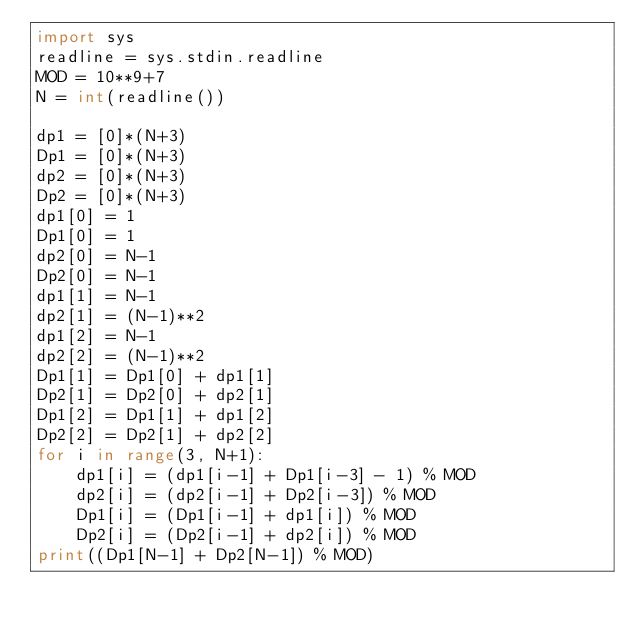<code> <loc_0><loc_0><loc_500><loc_500><_Python_>import sys
readline = sys.stdin.readline
MOD = 10**9+7
N = int(readline())

dp1 = [0]*(N+3)
Dp1 = [0]*(N+3)
dp2 = [0]*(N+3)
Dp2 = [0]*(N+3)
dp1[0] = 1
Dp1[0] = 1
dp2[0] = N-1
Dp2[0] = N-1
dp1[1] = N-1
dp2[1] = (N-1)**2
dp1[2] = N-1
dp2[2] = (N-1)**2
Dp1[1] = Dp1[0] + dp1[1]
Dp2[1] = Dp2[0] + dp2[1]
Dp1[2] = Dp1[1] + dp1[2]
Dp2[2] = Dp2[1] + dp2[2]
for i in range(3, N+1):
    dp1[i] = (dp1[i-1] + Dp1[i-3] - 1) % MOD
    dp2[i] = (dp2[i-1] + Dp2[i-3]) % MOD
    Dp1[i] = (Dp1[i-1] + dp1[i]) % MOD
    Dp2[i] = (Dp2[i-1] + dp2[i]) % MOD
print((Dp1[N-1] + Dp2[N-1]) % MOD)                 
</code> 